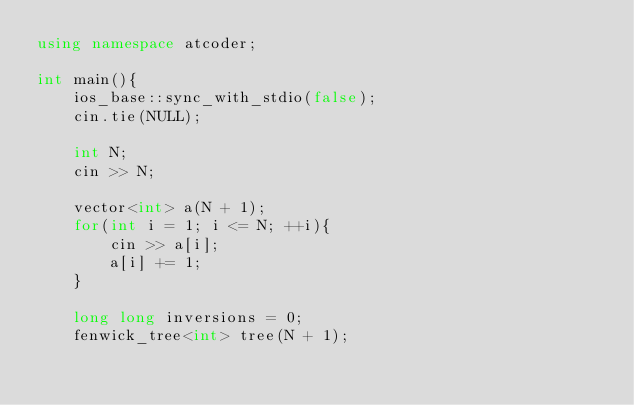<code> <loc_0><loc_0><loc_500><loc_500><_C++_>using namespace atcoder;

int main(){
    ios_base::sync_with_stdio(false);
    cin.tie(NULL);

    int N;
    cin >> N;

    vector<int> a(N + 1);
    for(int i = 1; i <= N; ++i){
        cin >> a[i];
        a[i] += 1;
    }

    long long inversions = 0;
    fenwick_tree<int> tree(N + 1);</code> 